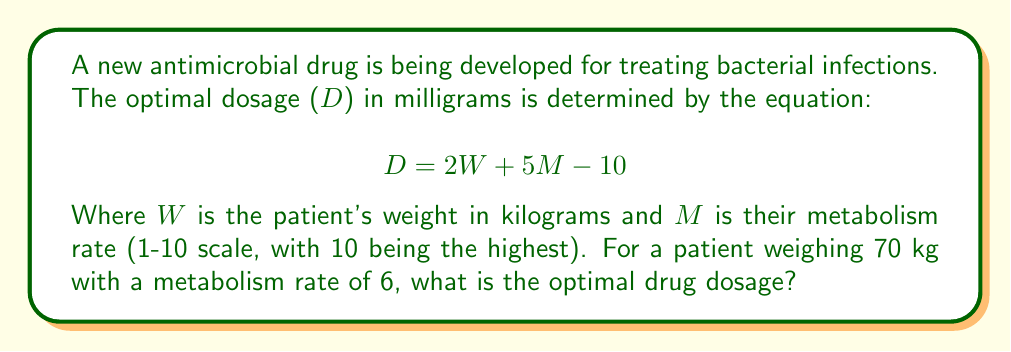Could you help me with this problem? To calculate the optimal drug dosage, we need to use the given equation and substitute the known values:

1) The equation is: $$D = 2W + 5M - 10$$

2) We know:
   - W (weight) = 70 kg
   - M (metabolism rate) = 6

3) Let's substitute these values into the equation:
   $$D = 2(70) + 5(6) - 10$$

4) First, let's calculate the terms inside the parentheses:
   $$D = 140 + 30 - 10$$

5) Now, we can perform the addition and subtraction from left to right:
   $$D = 170 - 10 = 160$$

Therefore, the optimal drug dosage for this patient is 160 mg.
Answer: 160 mg 